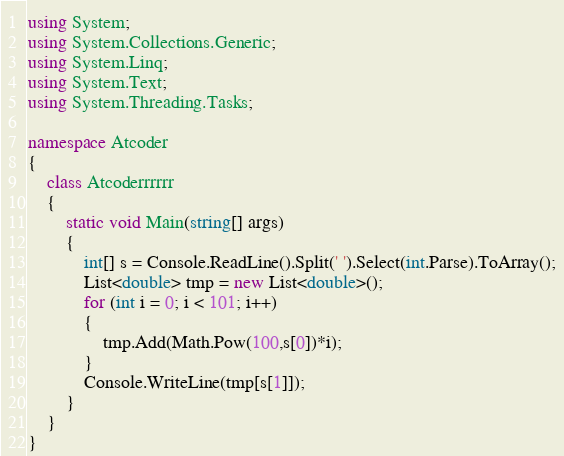Convert code to text. <code><loc_0><loc_0><loc_500><loc_500><_C#_>using System;
using System.Collections.Generic;
using System.Linq;
using System.Text;
using System.Threading.Tasks;

namespace Atcoder
{
    class Atcoderrrrrr
    {
        static void Main(string[] args)
        {
            int[] s = Console.ReadLine().Split(' ').Select(int.Parse).ToArray();
            List<double> tmp = new List<double>();
            for (int i = 0; i < 101; i++)
            {
                tmp.Add(Math.Pow(100,s[0])*i);
            }
            Console.WriteLine(tmp[s[1]]);
        }
    }
}</code> 